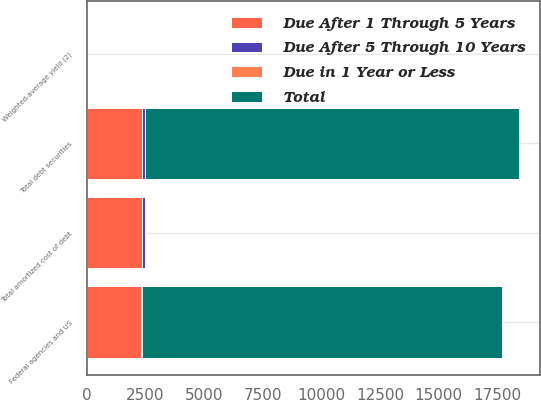<chart> <loc_0><loc_0><loc_500><loc_500><stacked_bar_chart><ecel><fcel>Federal agencies and US<fcel>Total debt securities<fcel>Total amortized cost of debt<fcel>Weighted-average yield (2)<nl><fcel>Due in 1 Year or Less<fcel>2<fcel>17<fcel>17<fcel>0.72<nl><fcel>Due After 5 Through 10 Years<fcel>53<fcel>104<fcel>104<fcel>4.77<nl><fcel>Due After 1 Through 5 Years<fcel>2318<fcel>2375<fcel>2375<fcel>1.76<nl><fcel>Total<fcel>15310<fcel>15915<fcel>53<fcel>2.74<nl></chart> 